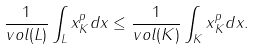<formula> <loc_0><loc_0><loc_500><loc_500>\frac { 1 } { v o l ( L ) } \int _ { L } \| x \| _ { K } ^ { p } d x \leq \frac { 1 } { v o l ( K ) } \int _ { K } \| x \| _ { K } ^ { p } d x .</formula> 